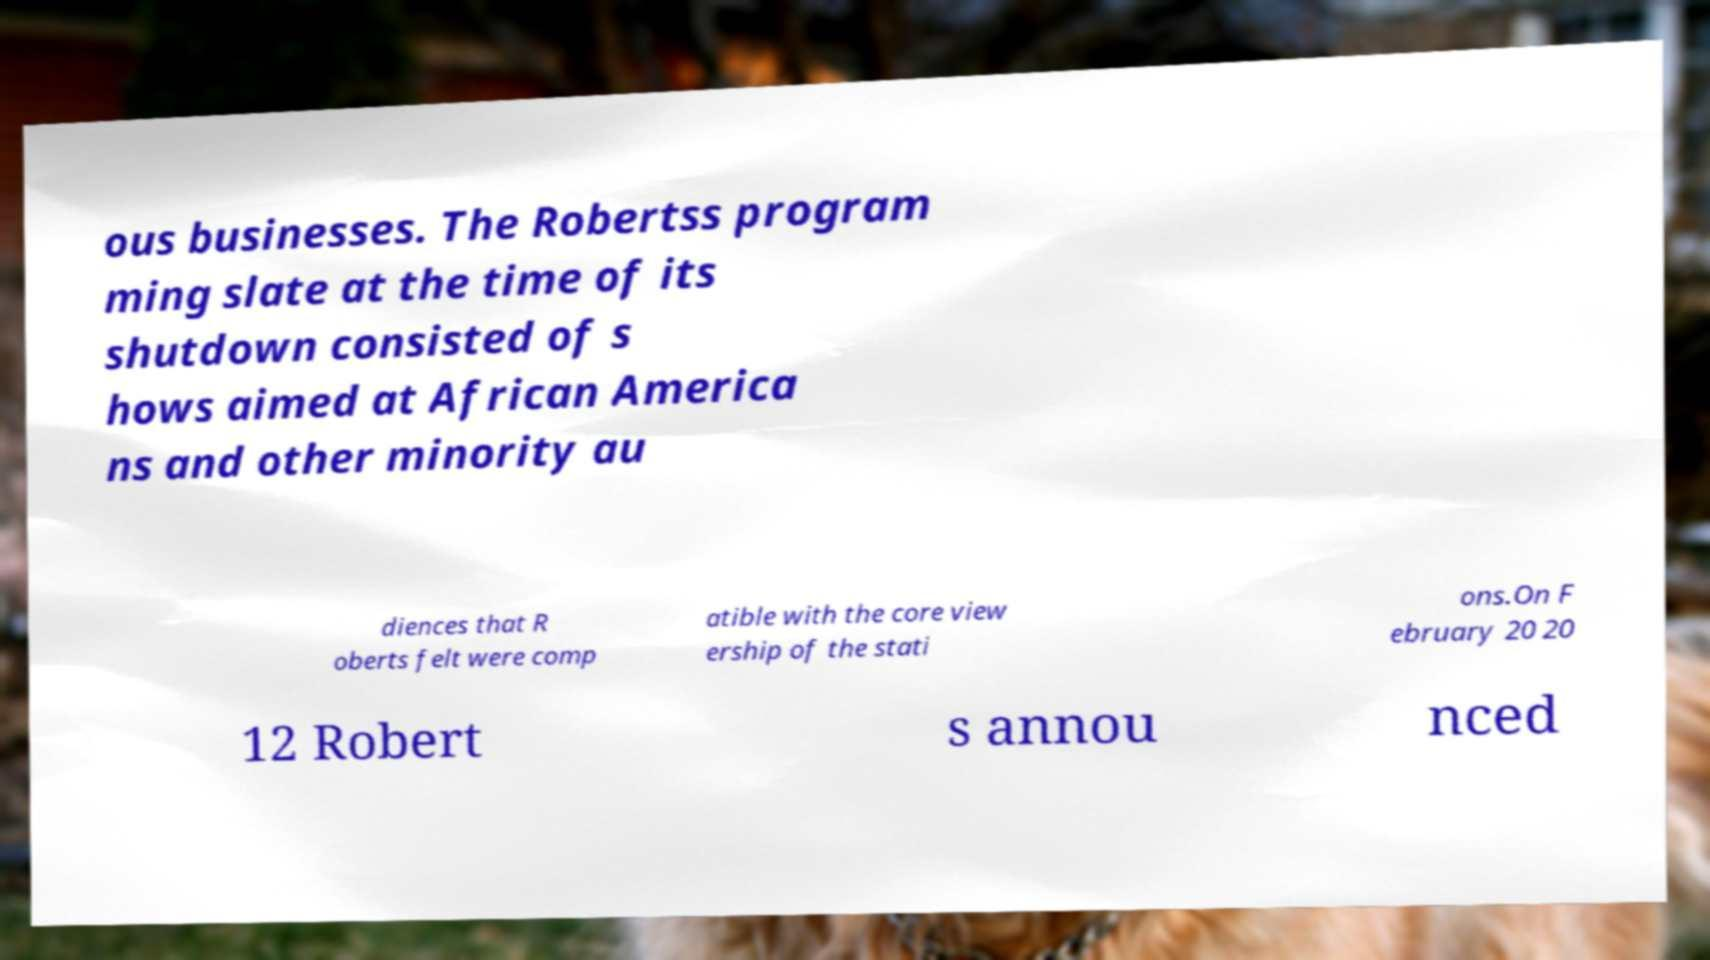Could you assist in decoding the text presented in this image and type it out clearly? ous businesses. The Robertss program ming slate at the time of its shutdown consisted of s hows aimed at African America ns and other minority au diences that R oberts felt were comp atible with the core view ership of the stati ons.On F ebruary 20 20 12 Robert s annou nced 